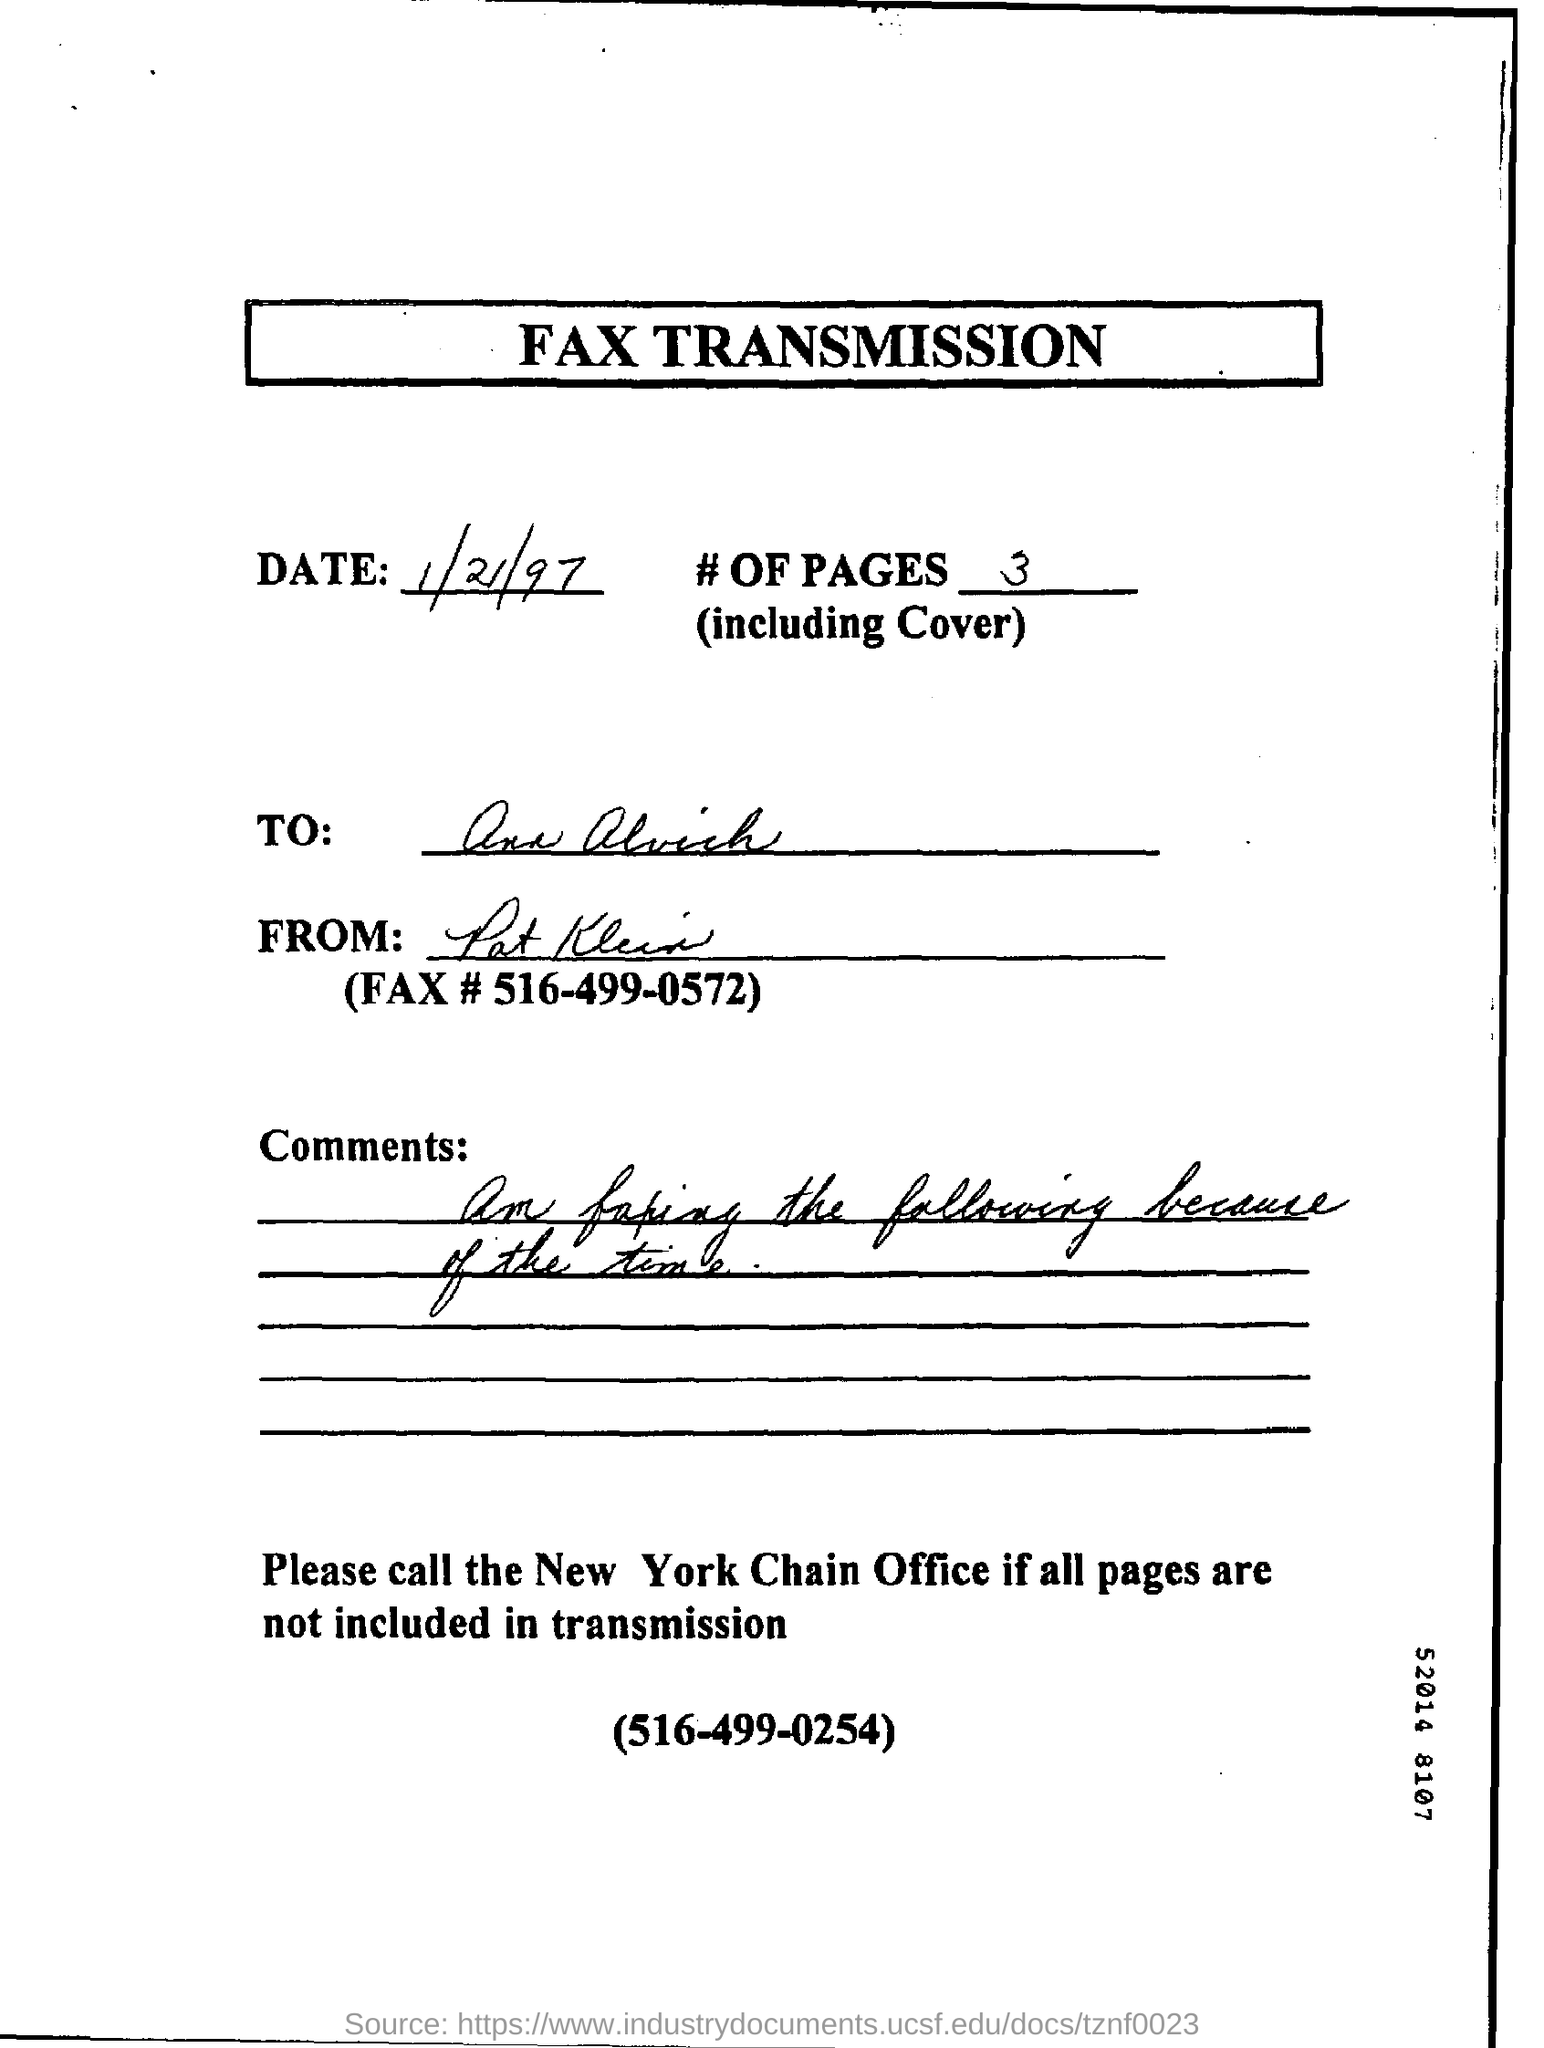Which form is this ?
Make the answer very short. Fax transmission. Which date is mentioned in the document ?
Give a very brief answer. 1/21/97. What is the contact number of New York Chain Office ?
Your response must be concise. 516-499-0254. 